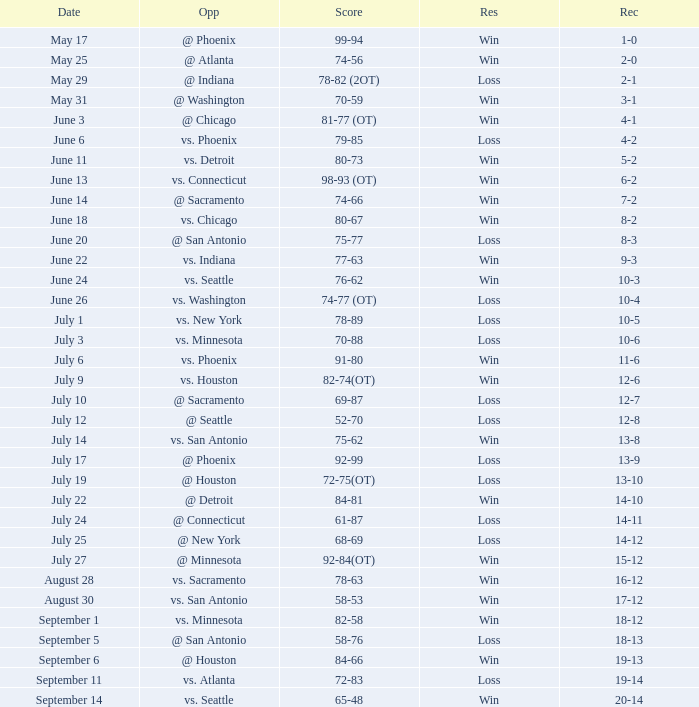Could you parse the entire table? {'header': ['Date', 'Opp', 'Score', 'Res', 'Rec'], 'rows': [['May 17', '@ Phoenix', '99-94', 'Win', '1-0'], ['May 25', '@ Atlanta', '74-56', 'Win', '2-0'], ['May 29', '@ Indiana', '78-82 (2OT)', 'Loss', '2-1'], ['May 31', '@ Washington', '70-59', 'Win', '3-1'], ['June 3', '@ Chicago', '81-77 (OT)', 'Win', '4-1'], ['June 6', 'vs. Phoenix', '79-85', 'Loss', '4-2'], ['June 11', 'vs. Detroit', '80-73', 'Win', '5-2'], ['June 13', 'vs. Connecticut', '98-93 (OT)', 'Win', '6-2'], ['June 14', '@ Sacramento', '74-66', 'Win', '7-2'], ['June 18', 'vs. Chicago', '80-67', 'Win', '8-2'], ['June 20', '@ San Antonio', '75-77', 'Loss', '8-3'], ['June 22', 'vs. Indiana', '77-63', 'Win', '9-3'], ['June 24', 'vs. Seattle', '76-62', 'Win', '10-3'], ['June 26', 'vs. Washington', '74-77 (OT)', 'Loss', '10-4'], ['July 1', 'vs. New York', '78-89', 'Loss', '10-5'], ['July 3', 'vs. Minnesota', '70-88', 'Loss', '10-6'], ['July 6', 'vs. Phoenix', '91-80', 'Win', '11-6'], ['July 9', 'vs. Houston', '82-74(OT)', 'Win', '12-6'], ['July 10', '@ Sacramento', '69-87', 'Loss', '12-7'], ['July 12', '@ Seattle', '52-70', 'Loss', '12-8'], ['July 14', 'vs. San Antonio', '75-62', 'Win', '13-8'], ['July 17', '@ Phoenix', '92-99', 'Loss', '13-9'], ['July 19', '@ Houston', '72-75(OT)', 'Loss', '13-10'], ['July 22', '@ Detroit', '84-81', 'Win', '14-10'], ['July 24', '@ Connecticut', '61-87', 'Loss', '14-11'], ['July 25', '@ New York', '68-69', 'Loss', '14-12'], ['July 27', '@ Minnesota', '92-84(OT)', 'Win', '15-12'], ['August 28', 'vs. Sacramento', '78-63', 'Win', '16-12'], ['August 30', 'vs. San Antonio', '58-53', 'Win', '17-12'], ['September 1', 'vs. Minnesota', '82-58', 'Win', '18-12'], ['September 5', '@ San Antonio', '58-76', 'Loss', '18-13'], ['September 6', '@ Houston', '84-66', 'Win', '19-13'], ['September 11', 'vs. Atlanta', '72-83', 'Loss', '19-14'], ['September 14', 'vs. Seattle', '65-48', 'Win', '20-14']]} What is the Record of the game with a Score of 65-48? 20-14. 